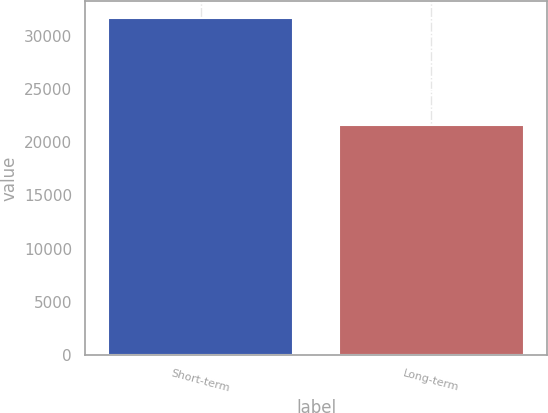Convert chart to OTSL. <chart><loc_0><loc_0><loc_500><loc_500><bar_chart><fcel>Short-term<fcel>Long-term<nl><fcel>31645<fcel>21619<nl></chart> 